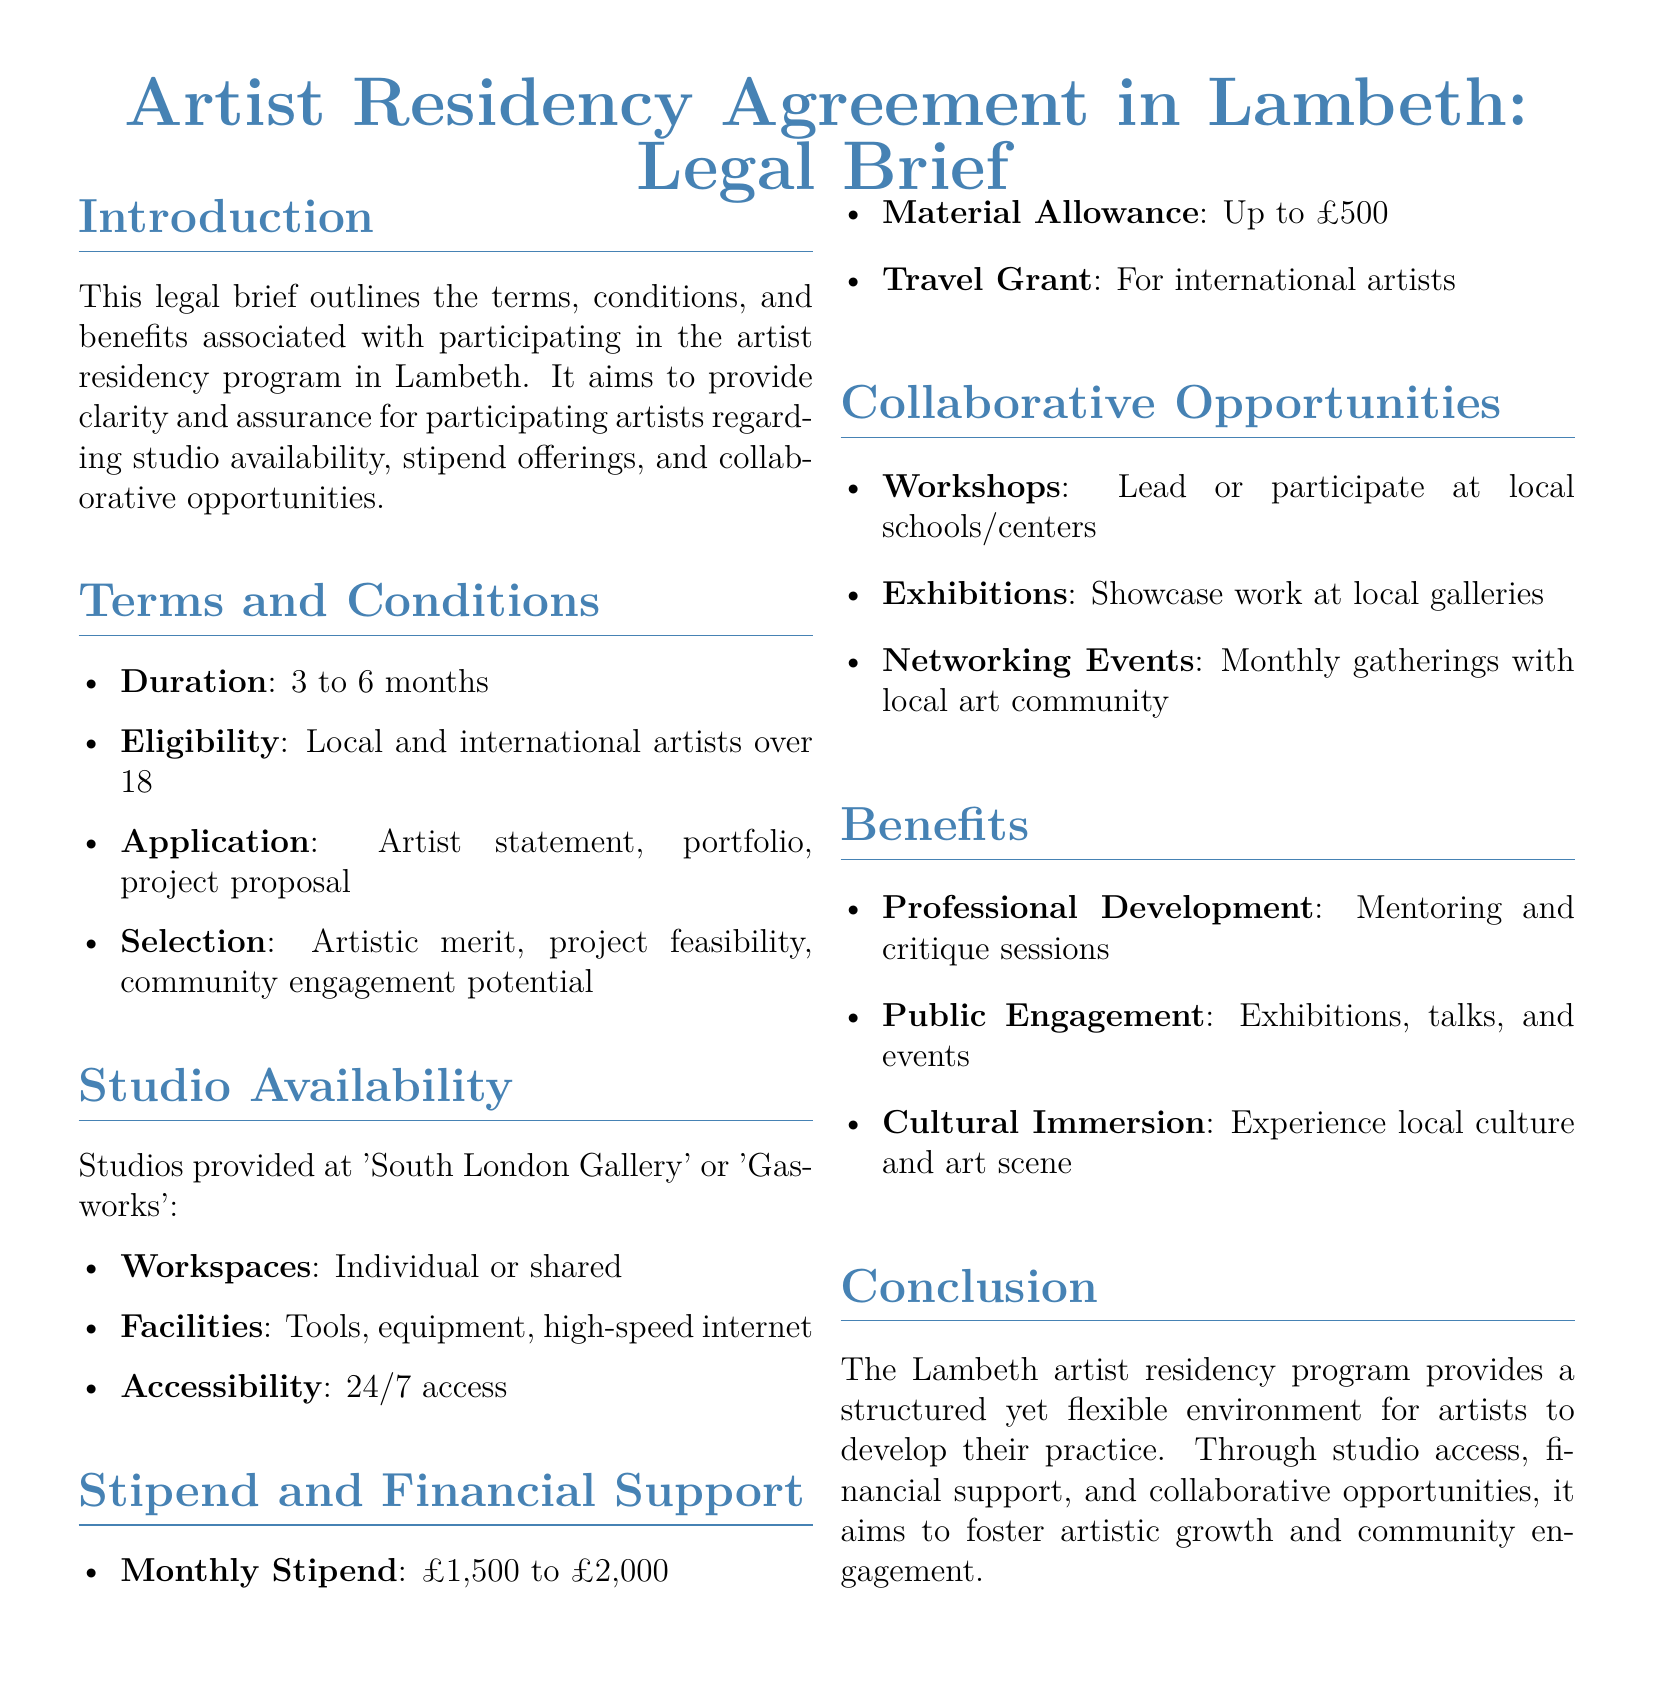What is the duration of the residency? The document states that the duration of the residency is between 3 to 6 months.
Answer: 3 to 6 months Who is eligible to apply? The eligibility criteria mentioned includes local and international artists over 18.
Answer: Local and international artists over 18 What is the monthly stipend range? The brief provides a monthly stipend range from £1,500 to £2,000.
Answer: £1,500 to £2,000 What facilities are available in the studios? The document lists tools, equipment, and high-speed internet as available facilities.
Answer: Tools, equipment, high-speed internet What types of collaborative opportunities are mentioned? The document mentions workshops, exhibitions, and networking events as collaborative opportunities.
Answer: Workshops, exhibitions, networking events What is the material allowance? The material allowance mentioned in the document is up to £500.
Answer: Up to £500 How often are networking events held? The brief specifies that networking events occur on a monthly basis.
Answer: Monthly What is the primary benefit offered for professional development? The document states that mentoring and critique sessions are a primary benefit for professional development.
Answer: Mentoring and critique sessions 